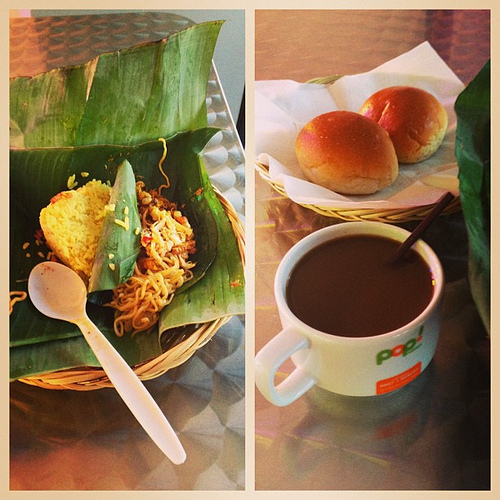Is the coffee in the white mug? Indeed, the coffee is in a white mug, which contrasts beautifully with the dark, aromatic contents it holds. 